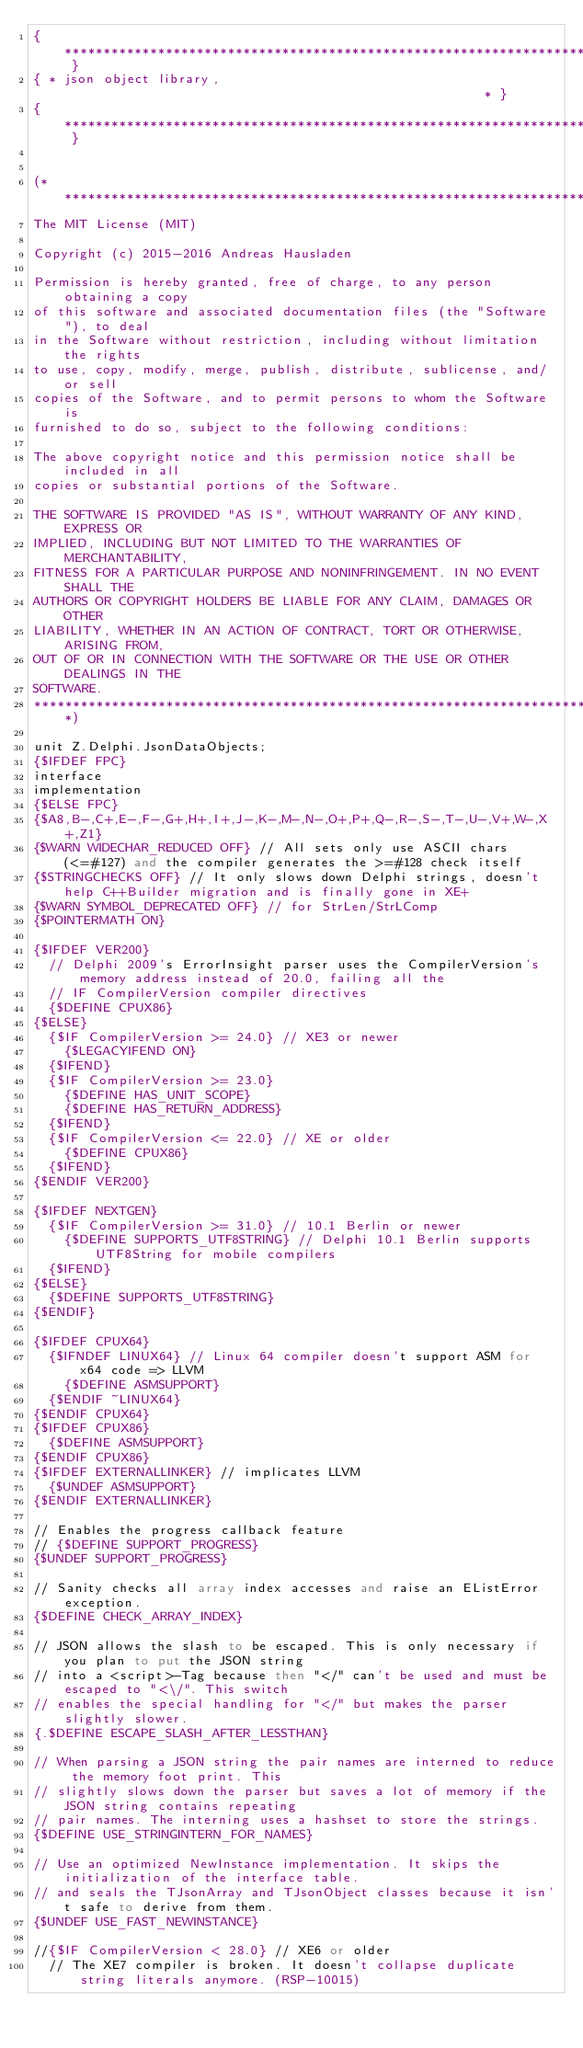<code> <loc_0><loc_0><loc_500><loc_500><_Pascal_>{ ****************************************************************************** }
{ * json object library,                                                       * }
{ ****************************************************************************** }


(*****************************************************************************
The MIT License (MIT)

Copyright (c) 2015-2016 Andreas Hausladen

Permission is hereby granted, free of charge, to any person obtaining a copy
of this software and associated documentation files (the "Software"), to deal
in the Software without restriction, including without limitation the rights
to use, copy, modify, merge, publish, distribute, sublicense, and/or sell
copies of the Software, and to permit persons to whom the Software is
furnished to do so, subject to the following conditions:

The above copyright notice and this permission notice shall be included in all
copies or substantial portions of the Software.

THE SOFTWARE IS PROVIDED "AS IS", WITHOUT WARRANTY OF ANY KIND, EXPRESS OR
IMPLIED, INCLUDING BUT NOT LIMITED TO THE WARRANTIES OF MERCHANTABILITY,
FITNESS FOR A PARTICULAR PURPOSE AND NONINFRINGEMENT. IN NO EVENT SHALL THE
AUTHORS OR COPYRIGHT HOLDERS BE LIABLE FOR ANY CLAIM, DAMAGES OR OTHER
LIABILITY, WHETHER IN AN ACTION OF CONTRACT, TORT OR OTHERWISE, ARISING FROM,
OUT OF OR IN CONNECTION WITH THE SOFTWARE OR THE USE OR OTHER DEALINGS IN THE
SOFTWARE.
*****************************************************************************)

unit Z.Delphi.JsonDataObjects;
{$IFDEF FPC}
interface
implementation
{$ELSE FPC}
{$A8,B-,C+,E-,F-,G+,H+,I+,J-,K-,M-,N-,O+,P+,Q-,R-,S-,T-,U-,V+,W-,X+,Z1}
{$WARN WIDECHAR_REDUCED OFF} // All sets only use ASCII chars (<=#127) and the compiler generates the >=#128 check itself
{$STRINGCHECKS OFF} // It only slows down Delphi strings, doesn't help C++Builder migration and is finally gone in XE+
{$WARN SYMBOL_DEPRECATED OFF} // for StrLen/StrLComp
{$POINTERMATH ON}

{$IFDEF VER200}
  // Delphi 2009's ErrorInsight parser uses the CompilerVersion's memory address instead of 20.0, failing all the
  // IF CompilerVersion compiler directives
  {$DEFINE CPUX86}
{$ELSE}
  {$IF CompilerVersion >= 24.0} // XE3 or newer
    {$LEGACYIFEND ON}
  {$IFEND}
  {$IF CompilerVersion >= 23.0}
    {$DEFINE HAS_UNIT_SCOPE}
    {$DEFINE HAS_RETURN_ADDRESS}
  {$IFEND}
  {$IF CompilerVersion <= 22.0} // XE or older
    {$DEFINE CPUX86}
  {$IFEND}
{$ENDIF VER200}

{$IFDEF NEXTGEN}
  {$IF CompilerVersion >= 31.0} // 10.1 Berlin or newer
    {$DEFINE SUPPORTS_UTF8STRING} // Delphi 10.1 Berlin supports UTF8String for mobile compilers
  {$IFEND}
{$ELSE}
  {$DEFINE SUPPORTS_UTF8STRING}
{$ENDIF}

{$IFDEF CPUX64}
  {$IFNDEF LINUX64} // Linux 64 compiler doesn't support ASM for x64 code => LLVM
    {$DEFINE ASMSUPPORT}
  {$ENDIF ~LINUX64}
{$ENDIF CPUX64}
{$IFDEF CPUX86}
  {$DEFINE ASMSUPPORT}
{$ENDIF CPUX86}
{$IFDEF EXTERNALLINKER} // implicates LLVM
  {$UNDEF ASMSUPPORT}
{$ENDIF EXTERNALLINKER}

// Enables the progress callback feature
// {$DEFINE SUPPORT_PROGRESS}
{$UNDEF SUPPORT_PROGRESS}

// Sanity checks all array index accesses and raise an EListError exception.
{$DEFINE CHECK_ARRAY_INDEX}

// JSON allows the slash to be escaped. This is only necessary if you plan to put the JSON string
// into a <script>-Tag because then "</" can't be used and must be escaped to "<\/". This switch
// enables the special handling for "</" but makes the parser slightly slower.
{.$DEFINE ESCAPE_SLASH_AFTER_LESSTHAN}

// When parsing a JSON string the pair names are interned to reduce the memory foot print. This
// slightly slows down the parser but saves a lot of memory if the JSON string contains repeating
// pair names. The interning uses a hashset to store the strings.
{$DEFINE USE_STRINGINTERN_FOR_NAMES}

// Use an optimized NewInstance implementation. It skips the initialization of the interface table.
// and seals the TJsonArray and TJsonObject classes because it isn't safe to derive from them.
{$UNDEF USE_FAST_NEWINSTANCE}

//{$IF CompilerVersion < 28.0} // XE6 or older
  // The XE7 compiler is broken. It doesn't collapse duplicate string literals anymore. (RSP-10015)</code> 